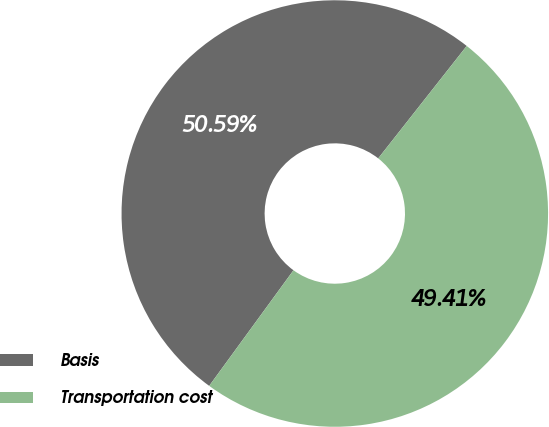Convert chart to OTSL. <chart><loc_0><loc_0><loc_500><loc_500><pie_chart><fcel>Basis<fcel>Transportation cost<nl><fcel>50.59%<fcel>49.41%<nl></chart> 